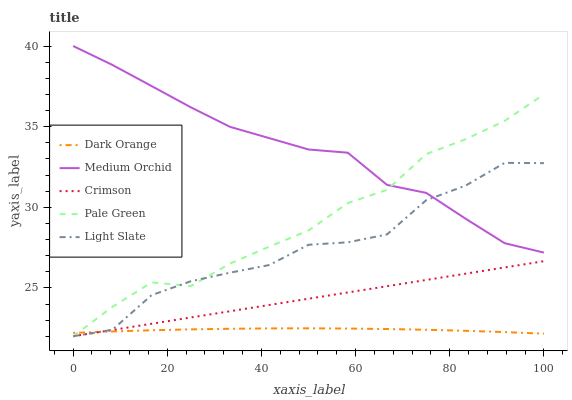Does Dark Orange have the minimum area under the curve?
Answer yes or no. Yes. Does Medium Orchid have the maximum area under the curve?
Answer yes or no. Yes. Does Pale Green have the minimum area under the curve?
Answer yes or no. No. Does Pale Green have the maximum area under the curve?
Answer yes or no. No. Is Crimson the smoothest?
Answer yes or no. Yes. Is Light Slate the roughest?
Answer yes or no. Yes. Is Dark Orange the smoothest?
Answer yes or no. No. Is Dark Orange the roughest?
Answer yes or no. No. Does Dark Orange have the lowest value?
Answer yes or no. No. Does Medium Orchid have the highest value?
Answer yes or no. Yes. Does Pale Green have the highest value?
Answer yes or no. No. Is Crimson less than Medium Orchid?
Answer yes or no. Yes. Is Medium Orchid greater than Dark Orange?
Answer yes or no. Yes. Does Crimson intersect Pale Green?
Answer yes or no. Yes. Is Crimson less than Pale Green?
Answer yes or no. No. Is Crimson greater than Pale Green?
Answer yes or no. No. Does Crimson intersect Medium Orchid?
Answer yes or no. No. 